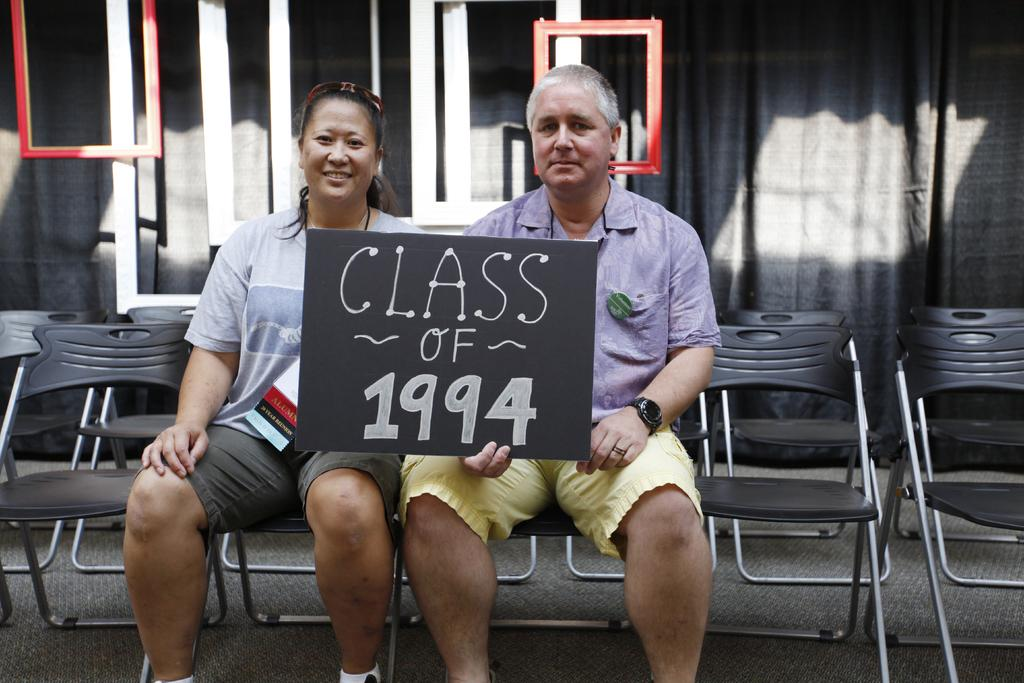Who is present in the image? There is a woman and a man in the image. What are the woman and the man holding? Both the woman and the man are holding a board. What is written on the board? The board says "Class Of 1994". What can be seen in the background of the image? There are chairs in the background of the image. What type of sun can be seen in the image? There is no sun present in the image. Where is the park located in the image? There is no park present in the image. 